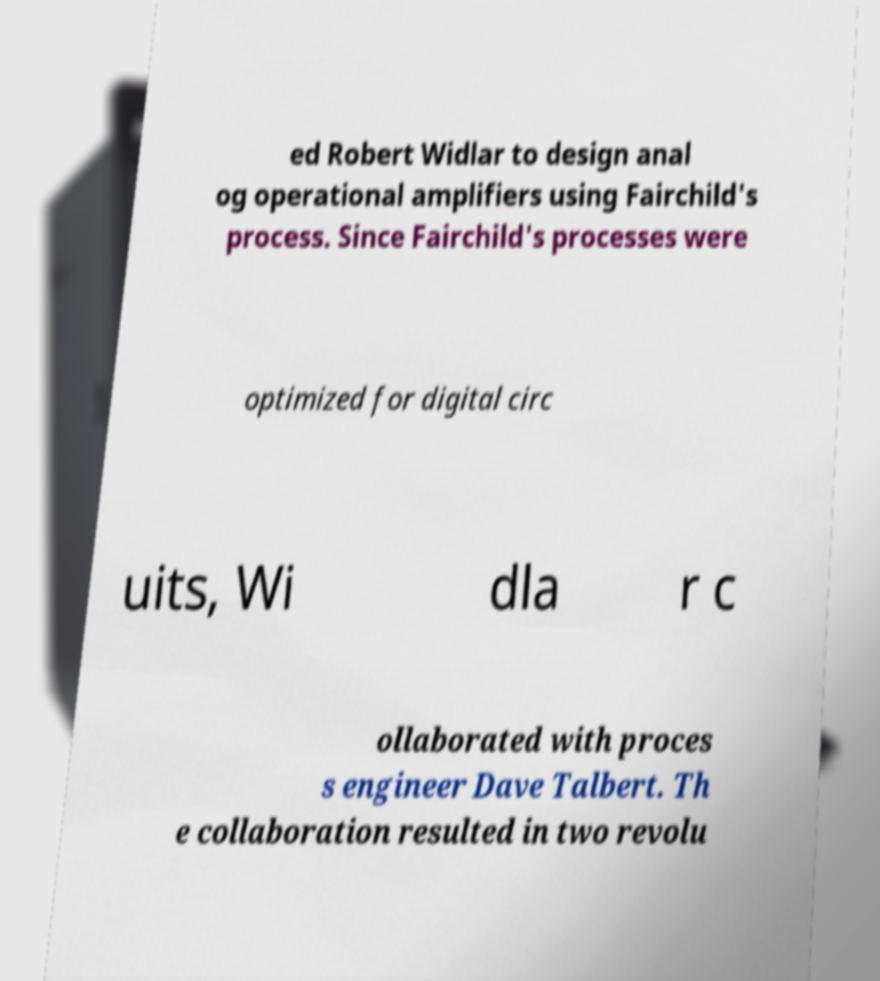For documentation purposes, I need the text within this image transcribed. Could you provide that? ed Robert Widlar to design anal og operational amplifiers using Fairchild's process. Since Fairchild's processes were optimized for digital circ uits, Wi dla r c ollaborated with proces s engineer Dave Talbert. Th e collaboration resulted in two revolu 